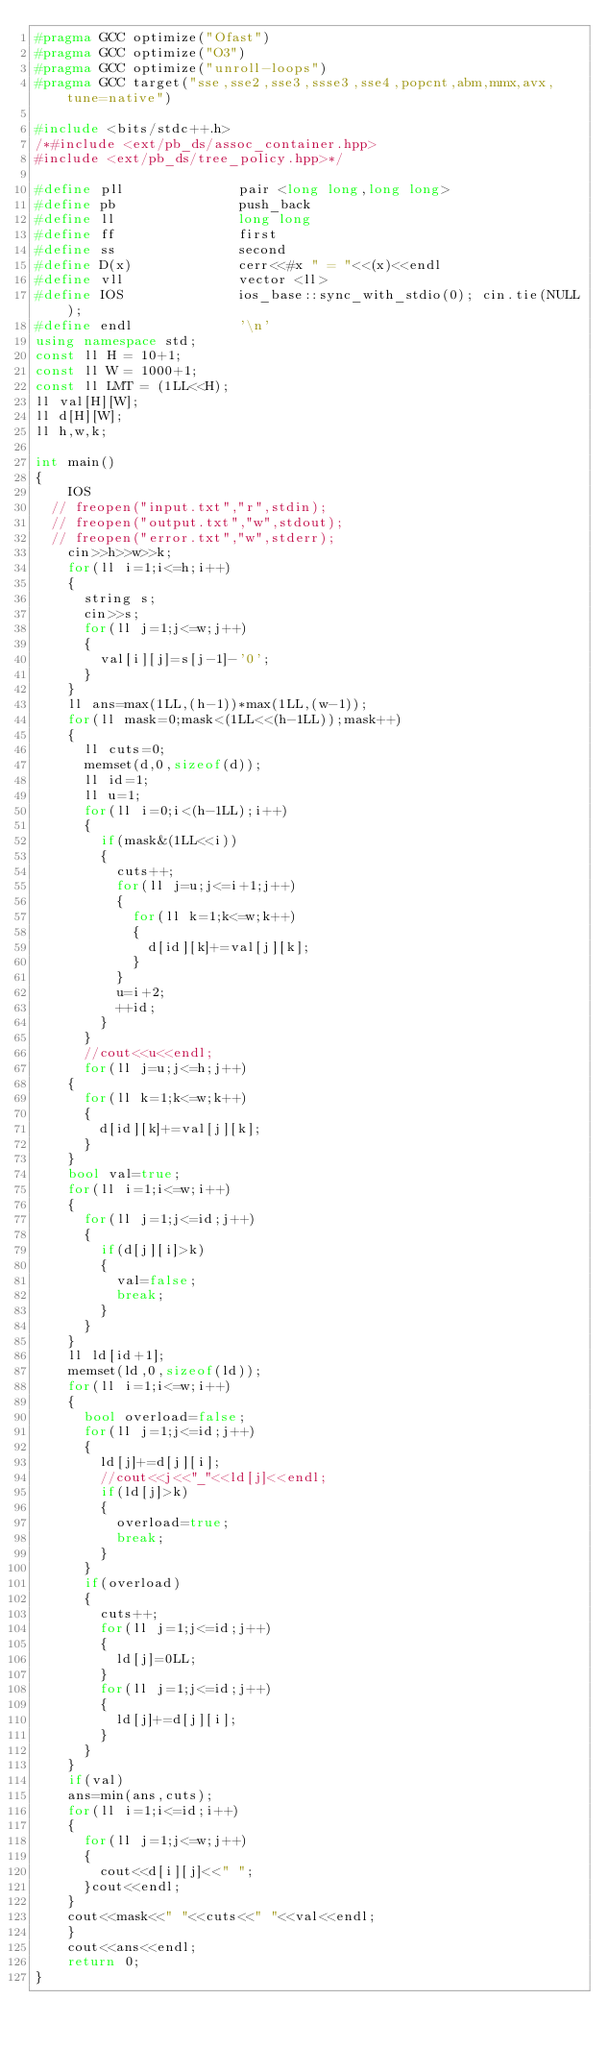<code> <loc_0><loc_0><loc_500><loc_500><_C++_>#pragma GCC optimize("Ofast")
#pragma GCC optimize("O3")
#pragma GCC optimize("unroll-loops")
#pragma GCC target("sse,sse2,sse3,ssse3,sse4,popcnt,abm,mmx,avx,tune=native")

#include <bits/stdc++.h>
/*#include <ext/pb_ds/assoc_container.hpp>
#include <ext/pb_ds/tree_policy.hpp>*/
 
#define pll              pair <long long,long long>
#define pb               push_back
#define ll               long long
#define ff               first
#define ss               second
#define D(x)             cerr<<#x " = "<<(x)<<endl
#define vll              vector <ll>
#define IOS              ios_base::sync_with_stdio(0); cin.tie(NULL);
#define endl             '\n'   
using namespace std;
const ll H = 10+1;
const ll W = 1000+1;
const ll LMT = (1LL<<H);
ll val[H][W];
ll d[H][W];
ll h,w,k;

int main()
{
    IOS
 	// freopen("input.txt","r",stdin);
 	// freopen("output.txt","w",stdout);
 	// freopen("error.txt","w",stderr);
    cin>>h>>w>>k;
    for(ll i=1;i<=h;i++)
    {
    	string s;
    	cin>>s;
    	for(ll j=1;j<=w;j++)
    	{
    		val[i][j]=s[j-1]-'0';
    	}
    }
    ll ans=max(1LL,(h-1))*max(1LL,(w-1));
    for(ll mask=0;mask<(1LL<<(h-1LL));mask++)
    {
    	ll cuts=0;
    	memset(d,0,sizeof(d));
    	ll id=1;
    	ll u=1;
    	for(ll i=0;i<(h-1LL);i++)
    	{
    		if(mask&(1LL<<i))
    		{
    			cuts++;
    			for(ll j=u;j<=i+1;j++)
    			{
    				for(ll k=1;k<=w;k++)
    				{
    					d[id][k]+=val[j][k];
    				}
    			}
    			u=i+2;
    			++id;
    		}
    	}
    	//cout<<u<<endl;
    	for(ll j=u;j<=h;j++)
		{
			for(ll k=1;k<=w;k++)
			{
				d[id][k]+=val[j][k];
			}
		}
		bool val=true;
		for(ll i=1;i<=w;i++)
		{
			for(ll j=1;j<=id;j++)
			{
				if(d[j][i]>k)
				{
					val=false;
					break;
				}
			}
		}
		ll ld[id+1];
		memset(ld,0,sizeof(ld));
		for(ll i=1;i<=w;i++)
		{
			bool overload=false;
			for(ll j=1;j<=id;j++)
			{
				ld[j]+=d[j][i];
				//cout<<j<<"_"<<ld[j]<<endl;
				if(ld[j]>k)
				{
					overload=true;
					break;
				}
			}
			if(overload)
			{
				cuts++;
				for(ll j=1;j<=id;j++)
				{
					ld[j]=0LL;
				}
				for(ll j=1;j<=id;j++)
				{
					ld[j]+=d[j][i];
				}
			}
		}
		if(val)
		ans=min(ans,cuts);
		for(ll i=1;i<=id;i++)
		{
			for(ll j=1;j<=w;j++)
			{
				cout<<d[i][j]<<" ";
			}cout<<endl;
		}
		cout<<mask<<" "<<cuts<<" "<<val<<endl;
    }
    cout<<ans<<endl;
    return 0;
}</code> 